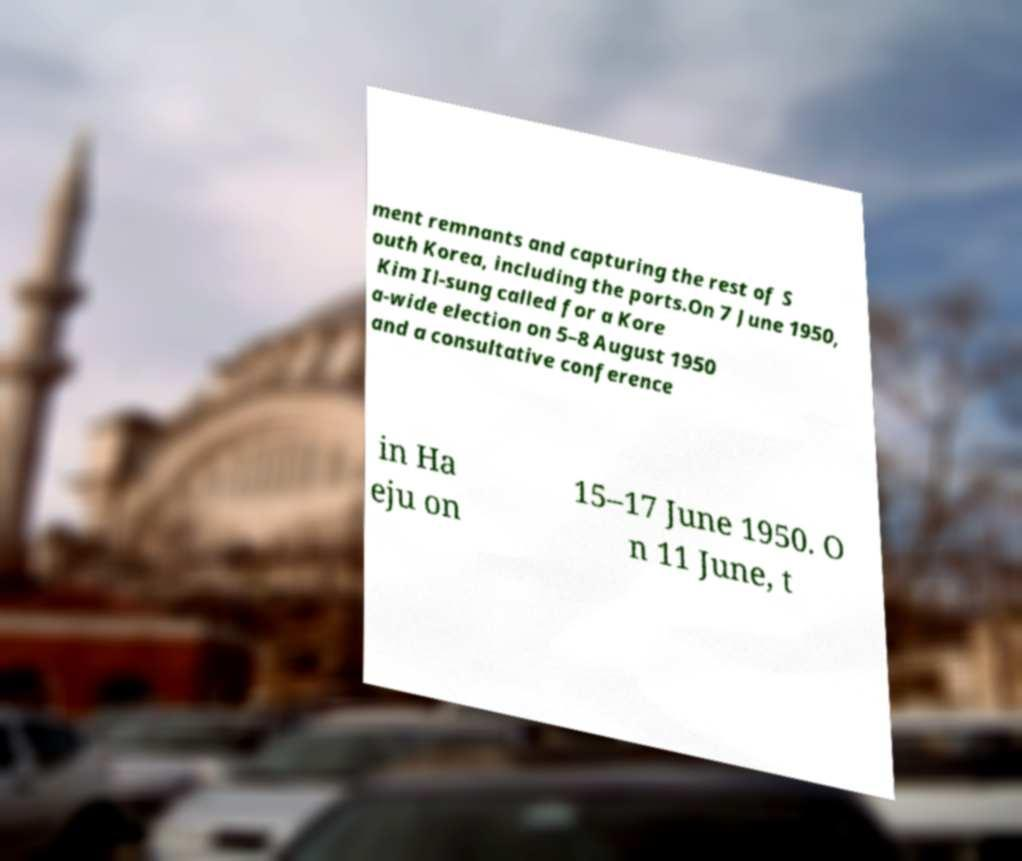Can you accurately transcribe the text from the provided image for me? ment remnants and capturing the rest of S outh Korea, including the ports.On 7 June 1950, Kim Il-sung called for a Kore a-wide election on 5–8 August 1950 and a consultative conference in Ha eju on 15–17 June 1950. O n 11 June, t 